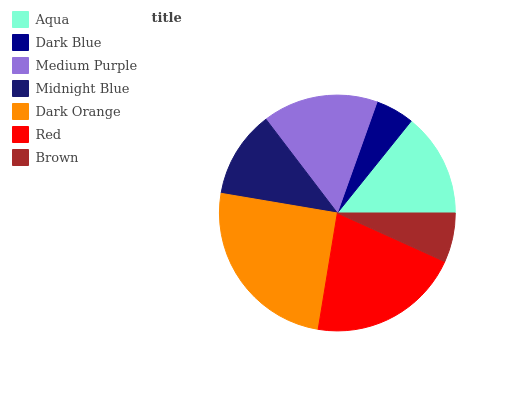Is Dark Blue the minimum?
Answer yes or no. Yes. Is Dark Orange the maximum?
Answer yes or no. Yes. Is Medium Purple the minimum?
Answer yes or no. No. Is Medium Purple the maximum?
Answer yes or no. No. Is Medium Purple greater than Dark Blue?
Answer yes or no. Yes. Is Dark Blue less than Medium Purple?
Answer yes or no. Yes. Is Dark Blue greater than Medium Purple?
Answer yes or no. No. Is Medium Purple less than Dark Blue?
Answer yes or no. No. Is Aqua the high median?
Answer yes or no. Yes. Is Aqua the low median?
Answer yes or no. Yes. Is Dark Orange the high median?
Answer yes or no. No. Is Medium Purple the low median?
Answer yes or no. No. 